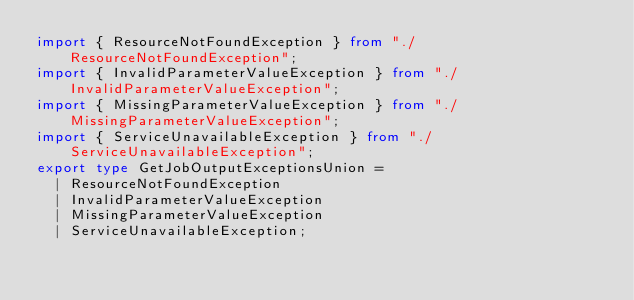<code> <loc_0><loc_0><loc_500><loc_500><_TypeScript_>import { ResourceNotFoundException } from "./ResourceNotFoundException";
import { InvalidParameterValueException } from "./InvalidParameterValueException";
import { MissingParameterValueException } from "./MissingParameterValueException";
import { ServiceUnavailableException } from "./ServiceUnavailableException";
export type GetJobOutputExceptionsUnion =
  | ResourceNotFoundException
  | InvalidParameterValueException
  | MissingParameterValueException
  | ServiceUnavailableException;
</code> 